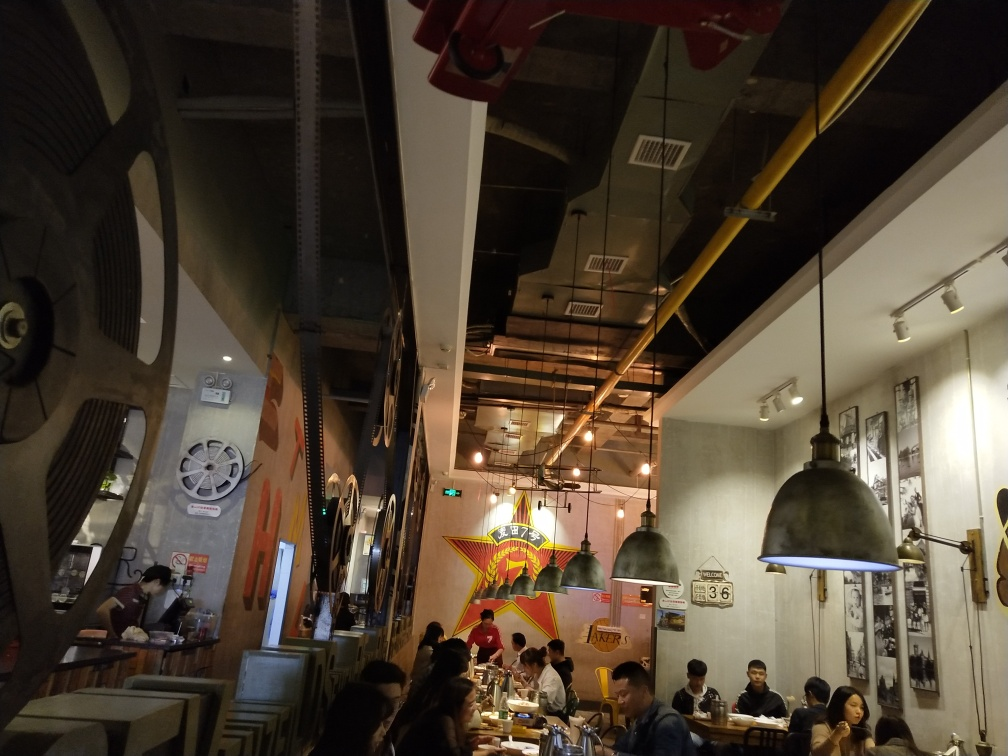Are there any quality issues with this image? Yes, there are a few quality issues with this image that can be improved. The photo is not taken with the correct orientation and appears to be sideways, which can affect the user's ability to accurately assess the scene. Additionally, the image seems a bit underexposed and could benefit from brightness adjustment to make the details clearer. Correcting these issues would enhance the overall quality of the image. 